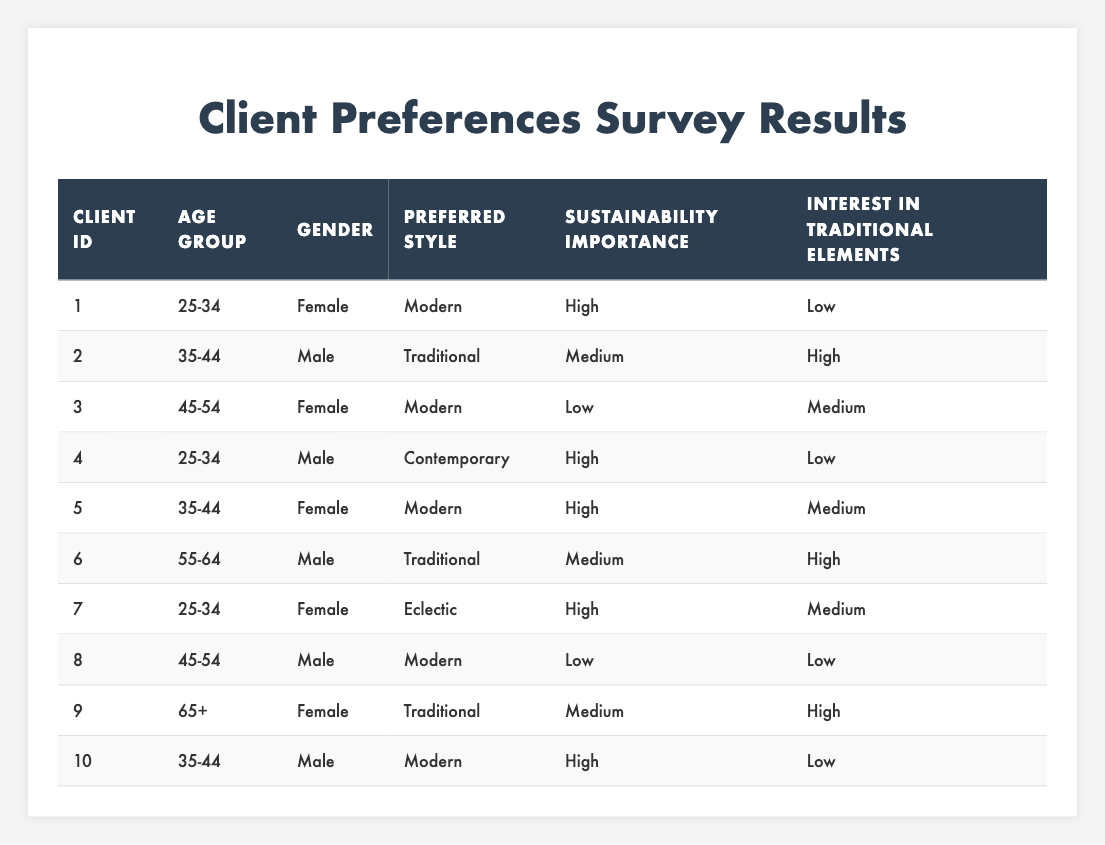What is the preferred style of the client with ID 3? Looking at the table, the preferred style for client ID 3 is listed in the "Preferred Style" column, which states "Modern."
Answer: Modern How many clients prefer the Traditional style? By scanning the "Preferred Style" column, we can count the number of entries marked as "Traditional." There are a total of 3 clients who selected this style (clients 2, 6, and 9).
Answer: 3 What age group is most represented among clients preferring Modern design? The clients preferring Modern design are IDs 1, 3, 5, 8, and 10. Their age groups are 25-34, 45-54, 35-44, 45-54, and 35-44 respectively. The 35-44 group is mentioned twice and 25-34 and 45-54 each once, showing that the most common age group among these clients is 35-44.
Answer: 35-44 Is there any client in the 55-64 age group who prefers Modern design? By reviewing the table for the 55-64 age group, client ID 6 is the only one listed there, and they prefer "Traditional," not "Modern." Thus, there are no clients in this age group with a Modern preference.
Answer: No What percentage of clients prioritize sustainability as 'High'? First, we identify the total number of clients, which is 10. Next, we count how many have "High" marked under the "Importance of Sustainability" column: clients 1, 4, 5, and 10, totaling 4 clients. Therefore, the percentage is (4/10) * 100 = 40%.
Answer: 40% Among clients aged 65 and older, what is the preferred style? The only client in the age group of 65+ is client ID 9, who has a preference for "Traditional" style listed in the "Preferred Style" column.
Answer: Traditional How many clients show a low interest in traditional elements? Looking at the "Interest in Traditional Elements" column, we see that clients 1, 4, 8, and 10 have "Low" indicated as their interest level, totaling 4 clients.
Answer: 4 Are there more female clients preferring Modern or Traditional styles? Count the female clients preferring Modern, which are clients 1, 3, and 5 (3 total), and for Traditional, there is only client 9. Since 3 is greater than 1, we conclude there are more female clients preferring Modern.
Answer: More prefer Modern What is the most common importance of sustainability rating among clients who prefer Contemporary design? There is only one client (client ID 4) that prefers Contemporary design, and their "Importance of Sustainability" is rated as "High." Hence, the most common rating is "High."
Answer: High What combination of client characteristics is found in client ID 7? Client ID 7 is a 25-34-year-old female who prefers "Eclectic" style, has a "High" rating for sustainability importance, and a "Medium" interest in traditional elements.
Answer: 25-34 Female Eclectic High Medium 